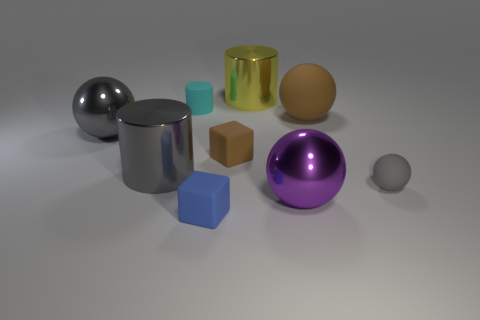Subtract all big spheres. How many spheres are left? 1 Subtract 2 cylinders. How many cylinders are left? 1 Subtract all purple balls. How many balls are left? 3 Subtract all blocks. How many objects are left? 7 Subtract all cyan cylinders. Subtract all cyan spheres. How many cylinders are left? 2 Subtract all yellow cubes. How many gray cylinders are left? 1 Subtract all gray spheres. Subtract all gray things. How many objects are left? 4 Add 1 small cyan matte cylinders. How many small cyan matte cylinders are left? 2 Add 9 small red metal cylinders. How many small red metal cylinders exist? 9 Subtract 0 blue cylinders. How many objects are left? 9 